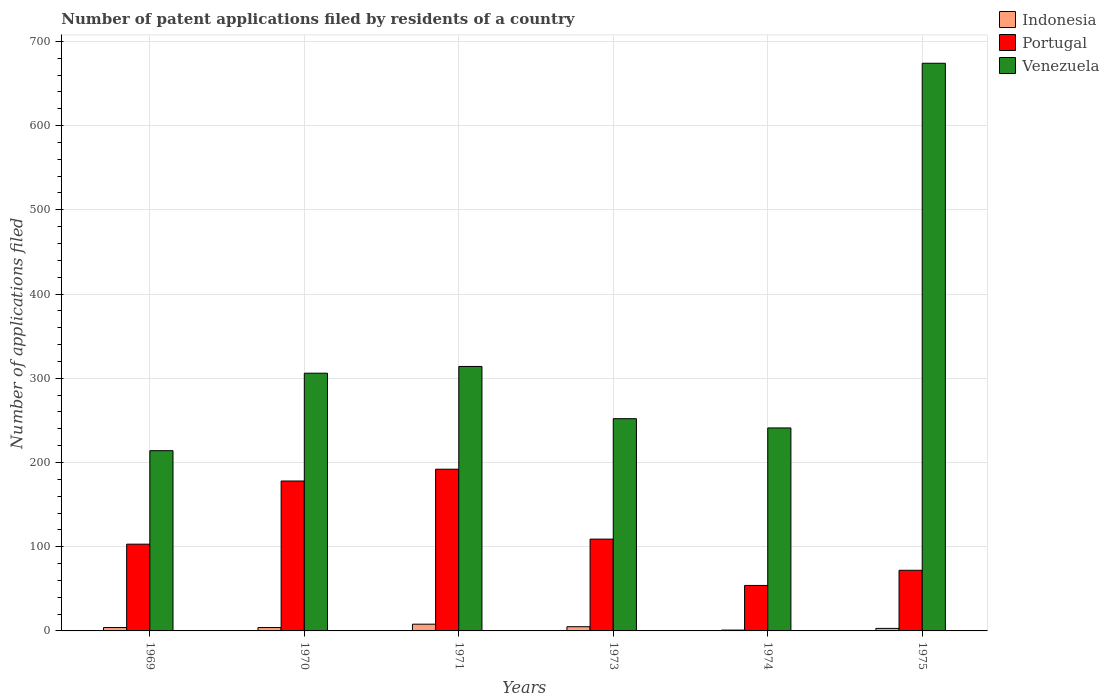How many groups of bars are there?
Your answer should be very brief. 6. Are the number of bars per tick equal to the number of legend labels?
Your answer should be very brief. Yes. How many bars are there on the 4th tick from the left?
Your response must be concise. 3. What is the label of the 6th group of bars from the left?
Make the answer very short. 1975. What is the number of applications filed in Portugal in 1973?
Your answer should be compact. 109. Across all years, what is the maximum number of applications filed in Indonesia?
Provide a succinct answer. 8. In which year was the number of applications filed in Venezuela maximum?
Give a very brief answer. 1975. In which year was the number of applications filed in Indonesia minimum?
Give a very brief answer. 1974. What is the total number of applications filed in Venezuela in the graph?
Your answer should be very brief. 2001. What is the difference between the number of applications filed in Venezuela in 1973 and the number of applications filed in Indonesia in 1974?
Keep it short and to the point. 251. What is the average number of applications filed in Venezuela per year?
Your answer should be compact. 333.5. In the year 1973, what is the difference between the number of applications filed in Indonesia and number of applications filed in Venezuela?
Provide a succinct answer. -247. What is the ratio of the number of applications filed in Venezuela in 1970 to that in 1973?
Your answer should be very brief. 1.21. Is the number of applications filed in Portugal in 1970 less than that in 1971?
Offer a terse response. Yes. Is the difference between the number of applications filed in Indonesia in 1970 and 1974 greater than the difference between the number of applications filed in Venezuela in 1970 and 1974?
Offer a terse response. No. What is the difference between the highest and the lowest number of applications filed in Indonesia?
Offer a very short reply. 7. What does the 3rd bar from the left in 1971 represents?
Make the answer very short. Venezuela. What does the 1st bar from the right in 1974 represents?
Your answer should be very brief. Venezuela. What is the difference between two consecutive major ticks on the Y-axis?
Keep it short and to the point. 100. Does the graph contain grids?
Give a very brief answer. Yes. How many legend labels are there?
Your answer should be compact. 3. What is the title of the graph?
Offer a terse response. Number of patent applications filed by residents of a country. What is the label or title of the X-axis?
Provide a succinct answer. Years. What is the label or title of the Y-axis?
Your response must be concise. Number of applications filed. What is the Number of applications filed in Indonesia in 1969?
Give a very brief answer. 4. What is the Number of applications filed of Portugal in 1969?
Offer a very short reply. 103. What is the Number of applications filed of Venezuela in 1969?
Your answer should be very brief. 214. What is the Number of applications filed in Portugal in 1970?
Your answer should be compact. 178. What is the Number of applications filed of Venezuela in 1970?
Ensure brevity in your answer.  306. What is the Number of applications filed of Indonesia in 1971?
Ensure brevity in your answer.  8. What is the Number of applications filed of Portugal in 1971?
Your answer should be very brief. 192. What is the Number of applications filed of Venezuela in 1971?
Offer a very short reply. 314. What is the Number of applications filed of Indonesia in 1973?
Keep it short and to the point. 5. What is the Number of applications filed in Portugal in 1973?
Give a very brief answer. 109. What is the Number of applications filed in Venezuela in 1973?
Make the answer very short. 252. What is the Number of applications filed of Portugal in 1974?
Your answer should be very brief. 54. What is the Number of applications filed of Venezuela in 1974?
Offer a very short reply. 241. What is the Number of applications filed in Portugal in 1975?
Give a very brief answer. 72. What is the Number of applications filed in Venezuela in 1975?
Keep it short and to the point. 674. Across all years, what is the maximum Number of applications filed of Indonesia?
Offer a very short reply. 8. Across all years, what is the maximum Number of applications filed in Portugal?
Make the answer very short. 192. Across all years, what is the maximum Number of applications filed of Venezuela?
Ensure brevity in your answer.  674. Across all years, what is the minimum Number of applications filed in Portugal?
Offer a terse response. 54. Across all years, what is the minimum Number of applications filed in Venezuela?
Make the answer very short. 214. What is the total Number of applications filed of Portugal in the graph?
Your response must be concise. 708. What is the total Number of applications filed of Venezuela in the graph?
Your answer should be compact. 2001. What is the difference between the Number of applications filed in Portugal in 1969 and that in 1970?
Give a very brief answer. -75. What is the difference between the Number of applications filed of Venezuela in 1969 and that in 1970?
Offer a terse response. -92. What is the difference between the Number of applications filed of Portugal in 1969 and that in 1971?
Give a very brief answer. -89. What is the difference between the Number of applications filed in Venezuela in 1969 and that in 1971?
Give a very brief answer. -100. What is the difference between the Number of applications filed in Portugal in 1969 and that in 1973?
Provide a short and direct response. -6. What is the difference between the Number of applications filed of Venezuela in 1969 and that in 1973?
Make the answer very short. -38. What is the difference between the Number of applications filed in Portugal in 1969 and that in 1974?
Make the answer very short. 49. What is the difference between the Number of applications filed of Venezuela in 1969 and that in 1974?
Provide a short and direct response. -27. What is the difference between the Number of applications filed of Portugal in 1969 and that in 1975?
Keep it short and to the point. 31. What is the difference between the Number of applications filed in Venezuela in 1969 and that in 1975?
Ensure brevity in your answer.  -460. What is the difference between the Number of applications filed of Indonesia in 1970 and that in 1971?
Provide a short and direct response. -4. What is the difference between the Number of applications filed in Portugal in 1970 and that in 1971?
Provide a succinct answer. -14. What is the difference between the Number of applications filed in Venezuela in 1970 and that in 1971?
Offer a very short reply. -8. What is the difference between the Number of applications filed in Portugal in 1970 and that in 1973?
Offer a terse response. 69. What is the difference between the Number of applications filed in Venezuela in 1970 and that in 1973?
Provide a succinct answer. 54. What is the difference between the Number of applications filed of Portugal in 1970 and that in 1974?
Offer a terse response. 124. What is the difference between the Number of applications filed in Portugal in 1970 and that in 1975?
Offer a very short reply. 106. What is the difference between the Number of applications filed of Venezuela in 1970 and that in 1975?
Give a very brief answer. -368. What is the difference between the Number of applications filed in Indonesia in 1971 and that in 1973?
Keep it short and to the point. 3. What is the difference between the Number of applications filed in Venezuela in 1971 and that in 1973?
Give a very brief answer. 62. What is the difference between the Number of applications filed of Indonesia in 1971 and that in 1974?
Your answer should be very brief. 7. What is the difference between the Number of applications filed of Portugal in 1971 and that in 1974?
Keep it short and to the point. 138. What is the difference between the Number of applications filed in Portugal in 1971 and that in 1975?
Keep it short and to the point. 120. What is the difference between the Number of applications filed of Venezuela in 1971 and that in 1975?
Your response must be concise. -360. What is the difference between the Number of applications filed in Indonesia in 1973 and that in 1974?
Your answer should be very brief. 4. What is the difference between the Number of applications filed of Indonesia in 1973 and that in 1975?
Your response must be concise. 2. What is the difference between the Number of applications filed in Portugal in 1973 and that in 1975?
Provide a short and direct response. 37. What is the difference between the Number of applications filed in Venezuela in 1973 and that in 1975?
Your answer should be compact. -422. What is the difference between the Number of applications filed of Indonesia in 1974 and that in 1975?
Provide a succinct answer. -2. What is the difference between the Number of applications filed of Venezuela in 1974 and that in 1975?
Offer a terse response. -433. What is the difference between the Number of applications filed of Indonesia in 1969 and the Number of applications filed of Portugal in 1970?
Ensure brevity in your answer.  -174. What is the difference between the Number of applications filed in Indonesia in 1969 and the Number of applications filed in Venezuela in 1970?
Ensure brevity in your answer.  -302. What is the difference between the Number of applications filed in Portugal in 1969 and the Number of applications filed in Venezuela in 1970?
Your answer should be very brief. -203. What is the difference between the Number of applications filed of Indonesia in 1969 and the Number of applications filed of Portugal in 1971?
Give a very brief answer. -188. What is the difference between the Number of applications filed in Indonesia in 1969 and the Number of applications filed in Venezuela in 1971?
Ensure brevity in your answer.  -310. What is the difference between the Number of applications filed in Portugal in 1969 and the Number of applications filed in Venezuela in 1971?
Provide a succinct answer. -211. What is the difference between the Number of applications filed of Indonesia in 1969 and the Number of applications filed of Portugal in 1973?
Your answer should be very brief. -105. What is the difference between the Number of applications filed of Indonesia in 1969 and the Number of applications filed of Venezuela in 1973?
Your answer should be compact. -248. What is the difference between the Number of applications filed of Portugal in 1969 and the Number of applications filed of Venezuela in 1973?
Your answer should be very brief. -149. What is the difference between the Number of applications filed of Indonesia in 1969 and the Number of applications filed of Portugal in 1974?
Your answer should be very brief. -50. What is the difference between the Number of applications filed in Indonesia in 1969 and the Number of applications filed in Venezuela in 1974?
Your answer should be compact. -237. What is the difference between the Number of applications filed of Portugal in 1969 and the Number of applications filed of Venezuela in 1974?
Your response must be concise. -138. What is the difference between the Number of applications filed of Indonesia in 1969 and the Number of applications filed of Portugal in 1975?
Provide a succinct answer. -68. What is the difference between the Number of applications filed of Indonesia in 1969 and the Number of applications filed of Venezuela in 1975?
Provide a short and direct response. -670. What is the difference between the Number of applications filed of Portugal in 1969 and the Number of applications filed of Venezuela in 1975?
Provide a succinct answer. -571. What is the difference between the Number of applications filed in Indonesia in 1970 and the Number of applications filed in Portugal in 1971?
Give a very brief answer. -188. What is the difference between the Number of applications filed of Indonesia in 1970 and the Number of applications filed of Venezuela in 1971?
Provide a succinct answer. -310. What is the difference between the Number of applications filed in Portugal in 1970 and the Number of applications filed in Venezuela in 1971?
Make the answer very short. -136. What is the difference between the Number of applications filed in Indonesia in 1970 and the Number of applications filed in Portugal in 1973?
Keep it short and to the point. -105. What is the difference between the Number of applications filed of Indonesia in 1970 and the Number of applications filed of Venezuela in 1973?
Offer a terse response. -248. What is the difference between the Number of applications filed in Portugal in 1970 and the Number of applications filed in Venezuela in 1973?
Your response must be concise. -74. What is the difference between the Number of applications filed in Indonesia in 1970 and the Number of applications filed in Venezuela in 1974?
Ensure brevity in your answer.  -237. What is the difference between the Number of applications filed of Portugal in 1970 and the Number of applications filed of Venezuela in 1974?
Provide a short and direct response. -63. What is the difference between the Number of applications filed in Indonesia in 1970 and the Number of applications filed in Portugal in 1975?
Your response must be concise. -68. What is the difference between the Number of applications filed of Indonesia in 1970 and the Number of applications filed of Venezuela in 1975?
Offer a very short reply. -670. What is the difference between the Number of applications filed of Portugal in 1970 and the Number of applications filed of Venezuela in 1975?
Offer a terse response. -496. What is the difference between the Number of applications filed of Indonesia in 1971 and the Number of applications filed of Portugal in 1973?
Offer a very short reply. -101. What is the difference between the Number of applications filed in Indonesia in 1971 and the Number of applications filed in Venezuela in 1973?
Provide a short and direct response. -244. What is the difference between the Number of applications filed in Portugal in 1971 and the Number of applications filed in Venezuela in 1973?
Your answer should be compact. -60. What is the difference between the Number of applications filed in Indonesia in 1971 and the Number of applications filed in Portugal in 1974?
Ensure brevity in your answer.  -46. What is the difference between the Number of applications filed of Indonesia in 1971 and the Number of applications filed of Venezuela in 1974?
Offer a very short reply. -233. What is the difference between the Number of applications filed in Portugal in 1971 and the Number of applications filed in Venezuela in 1974?
Ensure brevity in your answer.  -49. What is the difference between the Number of applications filed in Indonesia in 1971 and the Number of applications filed in Portugal in 1975?
Ensure brevity in your answer.  -64. What is the difference between the Number of applications filed of Indonesia in 1971 and the Number of applications filed of Venezuela in 1975?
Your answer should be compact. -666. What is the difference between the Number of applications filed of Portugal in 1971 and the Number of applications filed of Venezuela in 1975?
Your answer should be very brief. -482. What is the difference between the Number of applications filed in Indonesia in 1973 and the Number of applications filed in Portugal in 1974?
Ensure brevity in your answer.  -49. What is the difference between the Number of applications filed in Indonesia in 1973 and the Number of applications filed in Venezuela in 1974?
Provide a short and direct response. -236. What is the difference between the Number of applications filed in Portugal in 1973 and the Number of applications filed in Venezuela in 1974?
Give a very brief answer. -132. What is the difference between the Number of applications filed of Indonesia in 1973 and the Number of applications filed of Portugal in 1975?
Your answer should be very brief. -67. What is the difference between the Number of applications filed of Indonesia in 1973 and the Number of applications filed of Venezuela in 1975?
Offer a terse response. -669. What is the difference between the Number of applications filed in Portugal in 1973 and the Number of applications filed in Venezuela in 1975?
Give a very brief answer. -565. What is the difference between the Number of applications filed of Indonesia in 1974 and the Number of applications filed of Portugal in 1975?
Provide a short and direct response. -71. What is the difference between the Number of applications filed in Indonesia in 1974 and the Number of applications filed in Venezuela in 1975?
Your answer should be compact. -673. What is the difference between the Number of applications filed in Portugal in 1974 and the Number of applications filed in Venezuela in 1975?
Ensure brevity in your answer.  -620. What is the average Number of applications filed in Indonesia per year?
Your response must be concise. 4.17. What is the average Number of applications filed in Portugal per year?
Your response must be concise. 118. What is the average Number of applications filed in Venezuela per year?
Offer a very short reply. 333.5. In the year 1969, what is the difference between the Number of applications filed in Indonesia and Number of applications filed in Portugal?
Ensure brevity in your answer.  -99. In the year 1969, what is the difference between the Number of applications filed of Indonesia and Number of applications filed of Venezuela?
Offer a terse response. -210. In the year 1969, what is the difference between the Number of applications filed of Portugal and Number of applications filed of Venezuela?
Give a very brief answer. -111. In the year 1970, what is the difference between the Number of applications filed in Indonesia and Number of applications filed in Portugal?
Offer a terse response. -174. In the year 1970, what is the difference between the Number of applications filed of Indonesia and Number of applications filed of Venezuela?
Your response must be concise. -302. In the year 1970, what is the difference between the Number of applications filed in Portugal and Number of applications filed in Venezuela?
Ensure brevity in your answer.  -128. In the year 1971, what is the difference between the Number of applications filed of Indonesia and Number of applications filed of Portugal?
Provide a short and direct response. -184. In the year 1971, what is the difference between the Number of applications filed in Indonesia and Number of applications filed in Venezuela?
Your answer should be very brief. -306. In the year 1971, what is the difference between the Number of applications filed in Portugal and Number of applications filed in Venezuela?
Make the answer very short. -122. In the year 1973, what is the difference between the Number of applications filed of Indonesia and Number of applications filed of Portugal?
Provide a short and direct response. -104. In the year 1973, what is the difference between the Number of applications filed in Indonesia and Number of applications filed in Venezuela?
Your answer should be compact. -247. In the year 1973, what is the difference between the Number of applications filed in Portugal and Number of applications filed in Venezuela?
Offer a very short reply. -143. In the year 1974, what is the difference between the Number of applications filed in Indonesia and Number of applications filed in Portugal?
Provide a succinct answer. -53. In the year 1974, what is the difference between the Number of applications filed of Indonesia and Number of applications filed of Venezuela?
Provide a short and direct response. -240. In the year 1974, what is the difference between the Number of applications filed of Portugal and Number of applications filed of Venezuela?
Give a very brief answer. -187. In the year 1975, what is the difference between the Number of applications filed of Indonesia and Number of applications filed of Portugal?
Give a very brief answer. -69. In the year 1975, what is the difference between the Number of applications filed of Indonesia and Number of applications filed of Venezuela?
Ensure brevity in your answer.  -671. In the year 1975, what is the difference between the Number of applications filed of Portugal and Number of applications filed of Venezuela?
Your answer should be very brief. -602. What is the ratio of the Number of applications filed in Indonesia in 1969 to that in 1970?
Offer a very short reply. 1. What is the ratio of the Number of applications filed in Portugal in 1969 to that in 1970?
Offer a very short reply. 0.58. What is the ratio of the Number of applications filed of Venezuela in 1969 to that in 1970?
Your answer should be compact. 0.7. What is the ratio of the Number of applications filed of Indonesia in 1969 to that in 1971?
Give a very brief answer. 0.5. What is the ratio of the Number of applications filed of Portugal in 1969 to that in 1971?
Your response must be concise. 0.54. What is the ratio of the Number of applications filed in Venezuela in 1969 to that in 1971?
Give a very brief answer. 0.68. What is the ratio of the Number of applications filed of Portugal in 1969 to that in 1973?
Offer a terse response. 0.94. What is the ratio of the Number of applications filed of Venezuela in 1969 to that in 1973?
Your answer should be compact. 0.85. What is the ratio of the Number of applications filed in Indonesia in 1969 to that in 1974?
Ensure brevity in your answer.  4. What is the ratio of the Number of applications filed in Portugal in 1969 to that in 1974?
Ensure brevity in your answer.  1.91. What is the ratio of the Number of applications filed in Venezuela in 1969 to that in 1974?
Offer a very short reply. 0.89. What is the ratio of the Number of applications filed of Portugal in 1969 to that in 1975?
Your answer should be very brief. 1.43. What is the ratio of the Number of applications filed of Venezuela in 1969 to that in 1975?
Keep it short and to the point. 0.32. What is the ratio of the Number of applications filed in Portugal in 1970 to that in 1971?
Offer a very short reply. 0.93. What is the ratio of the Number of applications filed in Venezuela in 1970 to that in 1971?
Give a very brief answer. 0.97. What is the ratio of the Number of applications filed of Indonesia in 1970 to that in 1973?
Offer a very short reply. 0.8. What is the ratio of the Number of applications filed of Portugal in 1970 to that in 1973?
Offer a very short reply. 1.63. What is the ratio of the Number of applications filed of Venezuela in 1970 to that in 1973?
Your answer should be very brief. 1.21. What is the ratio of the Number of applications filed of Portugal in 1970 to that in 1974?
Offer a very short reply. 3.3. What is the ratio of the Number of applications filed of Venezuela in 1970 to that in 1974?
Your response must be concise. 1.27. What is the ratio of the Number of applications filed of Indonesia in 1970 to that in 1975?
Keep it short and to the point. 1.33. What is the ratio of the Number of applications filed in Portugal in 1970 to that in 1975?
Provide a succinct answer. 2.47. What is the ratio of the Number of applications filed of Venezuela in 1970 to that in 1975?
Your answer should be compact. 0.45. What is the ratio of the Number of applications filed in Indonesia in 1971 to that in 1973?
Provide a succinct answer. 1.6. What is the ratio of the Number of applications filed in Portugal in 1971 to that in 1973?
Make the answer very short. 1.76. What is the ratio of the Number of applications filed of Venezuela in 1971 to that in 1973?
Keep it short and to the point. 1.25. What is the ratio of the Number of applications filed of Portugal in 1971 to that in 1974?
Offer a very short reply. 3.56. What is the ratio of the Number of applications filed in Venezuela in 1971 to that in 1974?
Give a very brief answer. 1.3. What is the ratio of the Number of applications filed of Indonesia in 1971 to that in 1975?
Your answer should be very brief. 2.67. What is the ratio of the Number of applications filed of Portugal in 1971 to that in 1975?
Keep it short and to the point. 2.67. What is the ratio of the Number of applications filed of Venezuela in 1971 to that in 1975?
Provide a succinct answer. 0.47. What is the ratio of the Number of applications filed in Portugal in 1973 to that in 1974?
Offer a very short reply. 2.02. What is the ratio of the Number of applications filed of Venezuela in 1973 to that in 1974?
Ensure brevity in your answer.  1.05. What is the ratio of the Number of applications filed in Portugal in 1973 to that in 1975?
Give a very brief answer. 1.51. What is the ratio of the Number of applications filed in Venezuela in 1973 to that in 1975?
Ensure brevity in your answer.  0.37. What is the ratio of the Number of applications filed in Portugal in 1974 to that in 1975?
Make the answer very short. 0.75. What is the ratio of the Number of applications filed in Venezuela in 1974 to that in 1975?
Make the answer very short. 0.36. What is the difference between the highest and the second highest Number of applications filed in Indonesia?
Your answer should be compact. 3. What is the difference between the highest and the second highest Number of applications filed of Venezuela?
Your answer should be very brief. 360. What is the difference between the highest and the lowest Number of applications filed in Portugal?
Offer a terse response. 138. What is the difference between the highest and the lowest Number of applications filed of Venezuela?
Give a very brief answer. 460. 